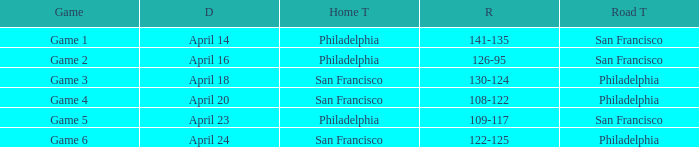What was the result of the game played on April 16 with Philadelphia as home team? 126-95. 